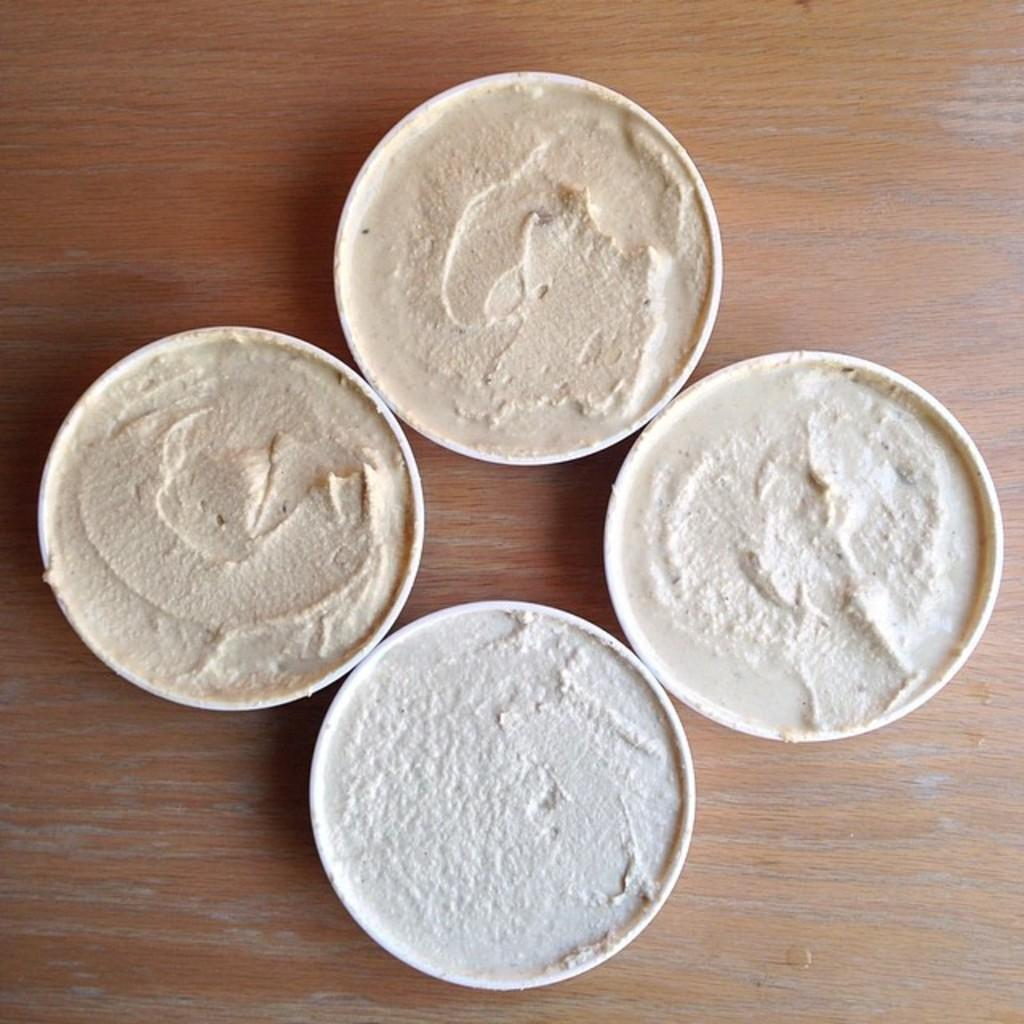How many bowls are visible in the image? There are four bowls in the image. What is inside the bowls? The bowls contain food items. What is the material of the surface the bowls are placed on? The surface the bowls are on is made of wood. How many goldfish are swimming in the bowls in the image? There are no goldfish present in the image; the bowls contain food items. 